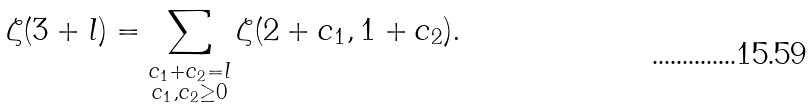<formula> <loc_0><loc_0><loc_500><loc_500>\zeta ( 3 + l ) = \sum _ { \substack { c _ { 1 } + c _ { 2 } = l \\ c _ { 1 } , c _ { 2 } \geq 0 } } \zeta ( 2 + c _ { 1 } , 1 + c _ { 2 } ) .</formula> 